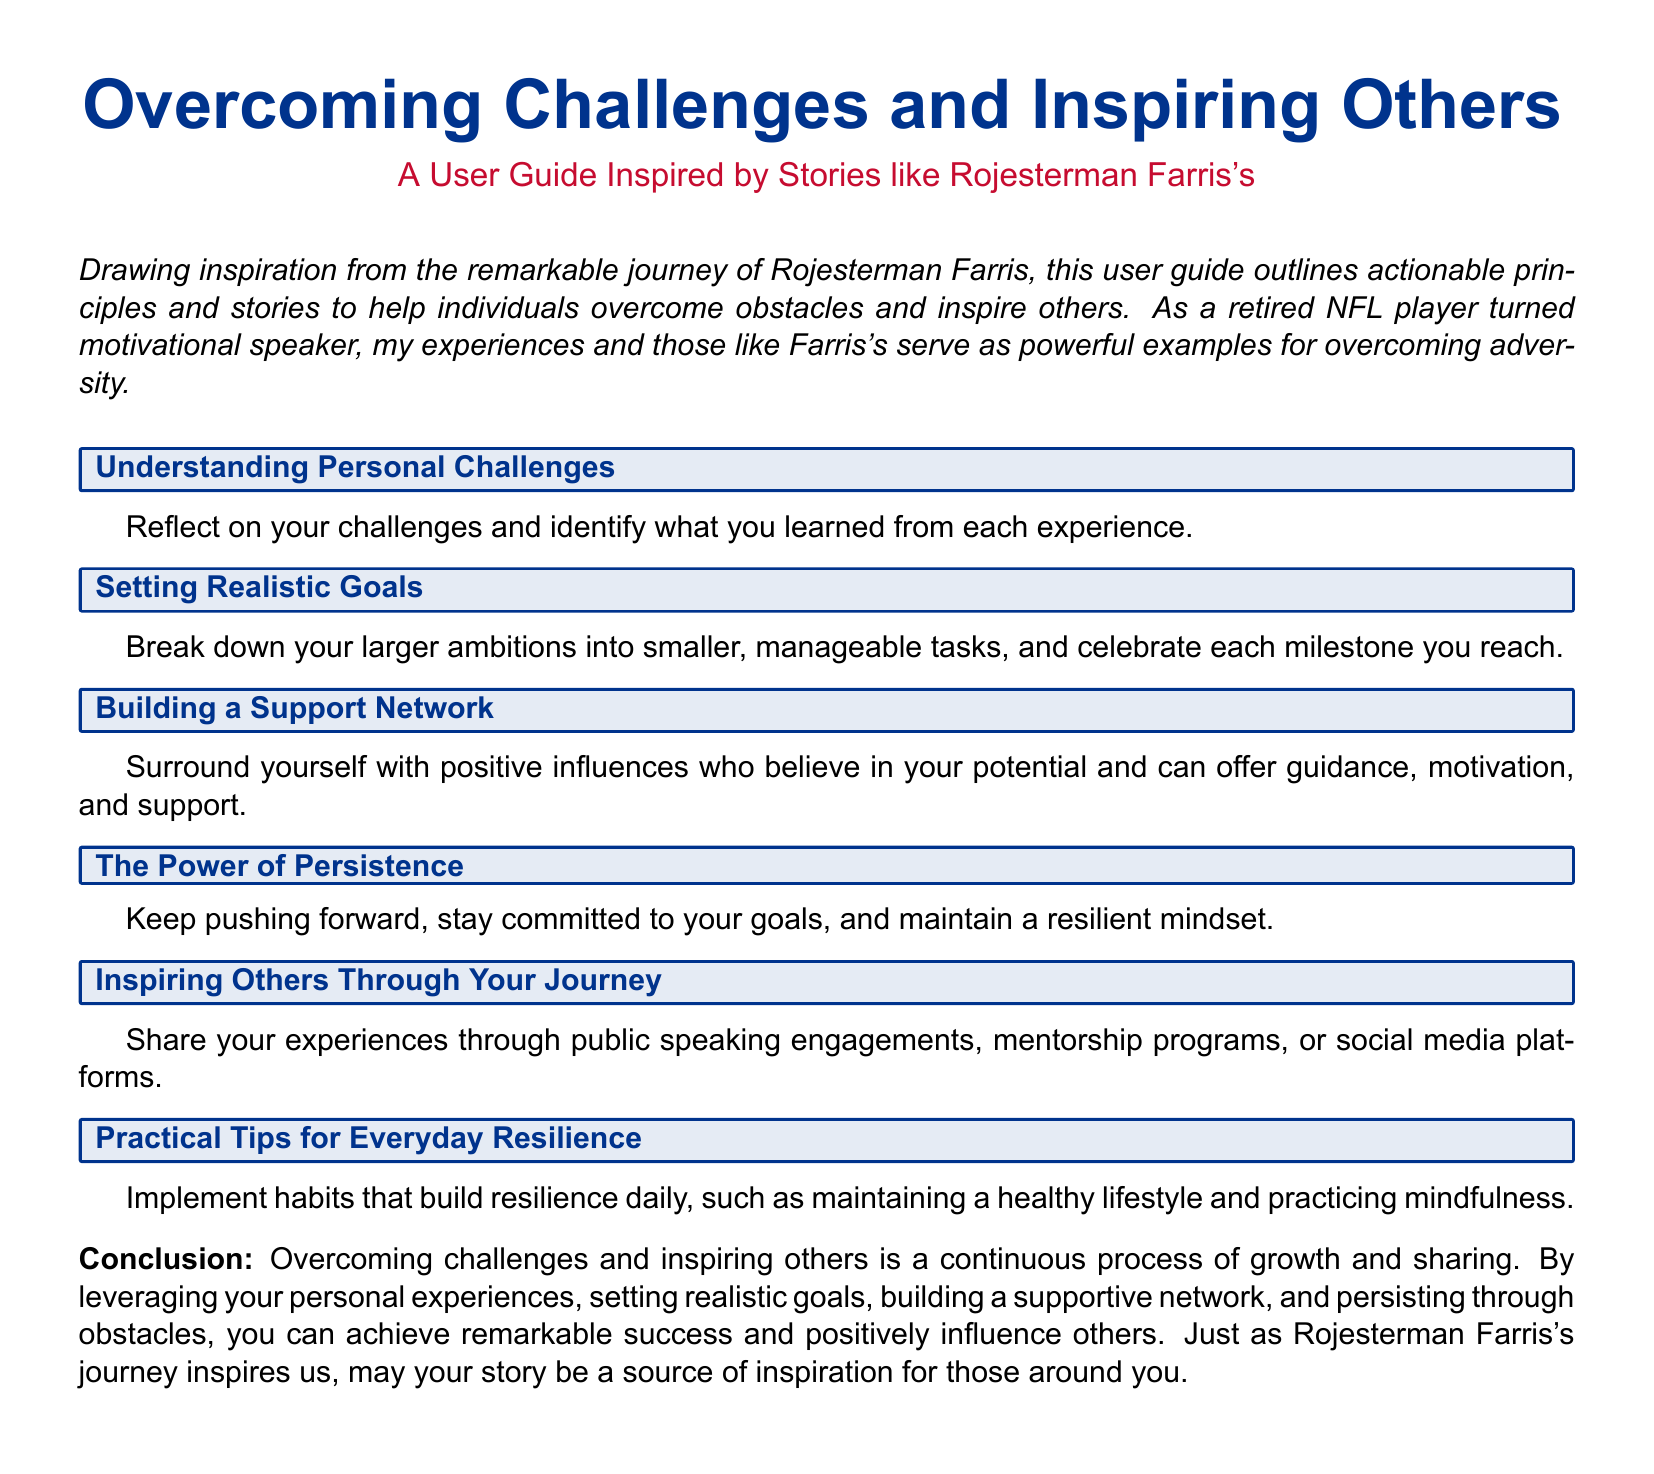What is the title of the user guide? The title is prominently displayed at the beginning of the document, providing the main theme of the guide.
Answer: Overcoming Challenges and Inspiring Others Who is the user guide inspired by? The document mentions that it draws inspiration from a specific individual's journey, providing a personal connection to the content.
Answer: Rojesterman Farris What is the color of the section headings? The section headings are designed with a specific color scheme that enhances visual appeal and consistency throughout the document.
Answer: nflblue What is one of the actionable principles outlined in the guide? The guide provides several actionable principles for readers to follow in order to overcome challenges and inspire others.
Answer: Building a Support Network What should individuals implement daily to build resilience? The guide suggests practical daily habits that support resilience and personal growth, which are essential for overcoming challenges.
Answer: Maintaining a healthy lifestyle 